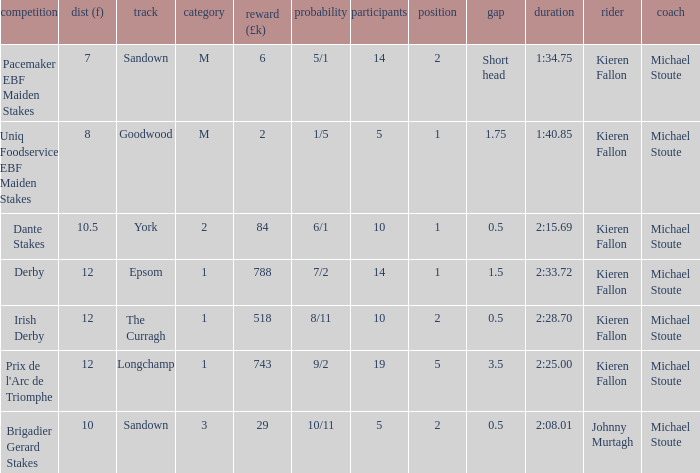Name the runners for longchamp 19.0. 